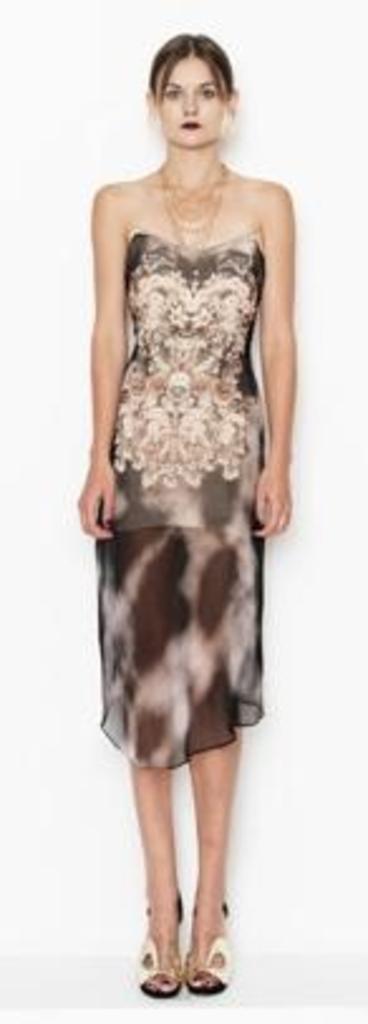How would you summarize this image in a sentence or two? In this image, I can see the woman standing. She wore a dress, necklace and sandals. The background looks white in color. 